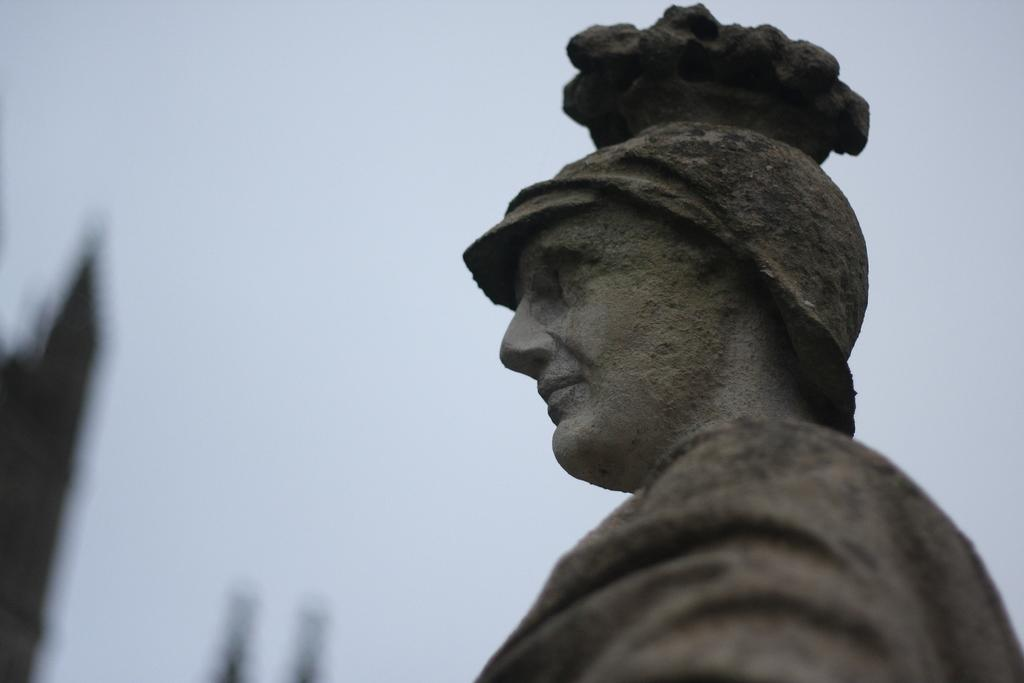What is the main subject of the image? There is a statue in the image. Can you describe the statue? The statue is of a person. How many trucks are visible in the image? There are no trucks visible in the image; it features a statue of a person. Is there a ghost present in the image? There is no ghost present in the image; it features a statue of a person. 